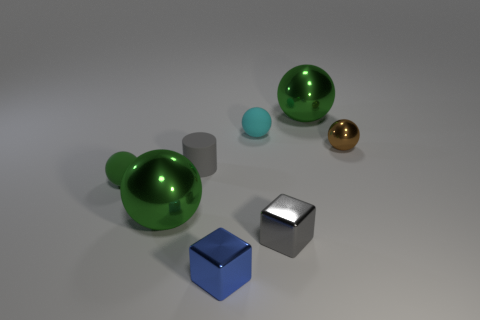Subtract all yellow cylinders. How many green spheres are left? 3 Subtract 2 balls. How many balls are left? 3 Subtract all tiny green spheres. How many spheres are left? 4 Subtract all brown balls. How many balls are left? 4 Add 1 brown things. How many objects exist? 9 Subtract all red spheres. Subtract all blue blocks. How many spheres are left? 5 Subtract all blocks. How many objects are left? 6 Add 3 tiny matte spheres. How many tiny matte spheres exist? 5 Subtract 1 brown balls. How many objects are left? 7 Subtract all small green spheres. Subtract all big green objects. How many objects are left? 5 